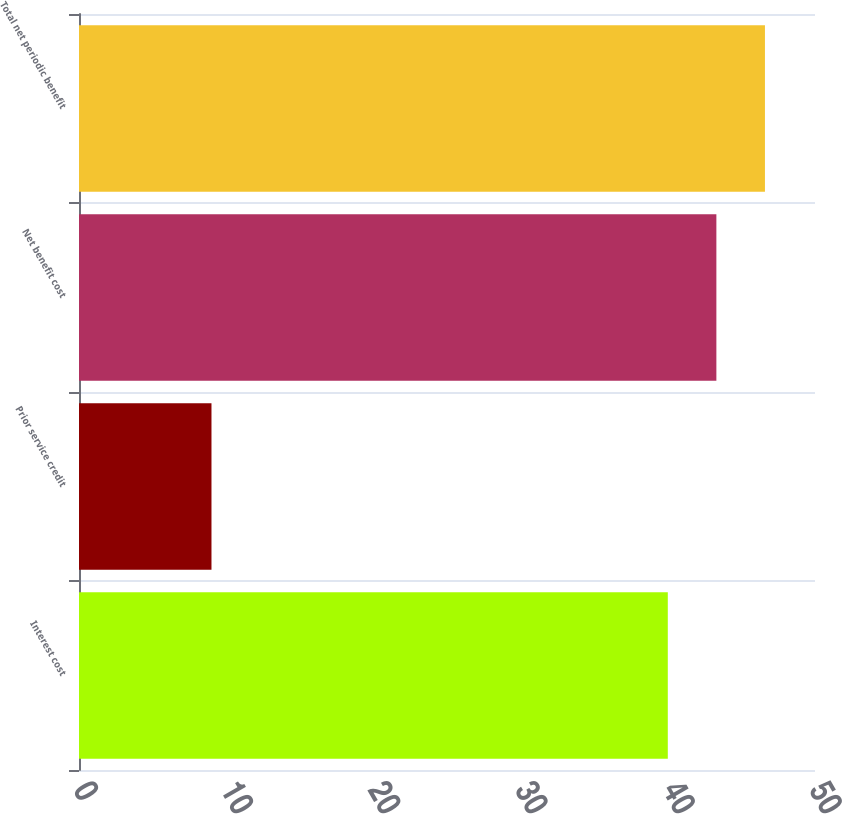<chart> <loc_0><loc_0><loc_500><loc_500><bar_chart><fcel>Interest cost<fcel>Prior service credit<fcel>Net benefit cost<fcel>Total net periodic benefit<nl><fcel>40<fcel>9<fcel>43.3<fcel>46.6<nl></chart> 